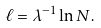<formula> <loc_0><loc_0><loc_500><loc_500>\ell = \lambda ^ { - 1 } \ln N .</formula> 